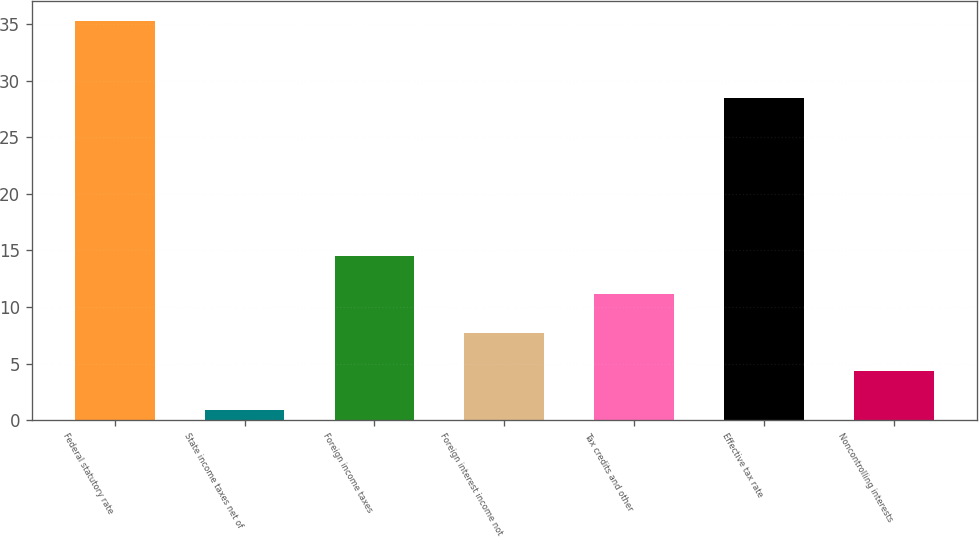Convert chart. <chart><loc_0><loc_0><loc_500><loc_500><bar_chart><fcel>Federal statutory rate<fcel>State income taxes net of<fcel>Foreign income taxes<fcel>Foreign interest income not<fcel>Tax credits and other<fcel>Effective tax rate<fcel>Noncontrolling interests<nl><fcel>35.32<fcel>0.9<fcel>14.54<fcel>7.72<fcel>11.13<fcel>28.5<fcel>4.31<nl></chart> 